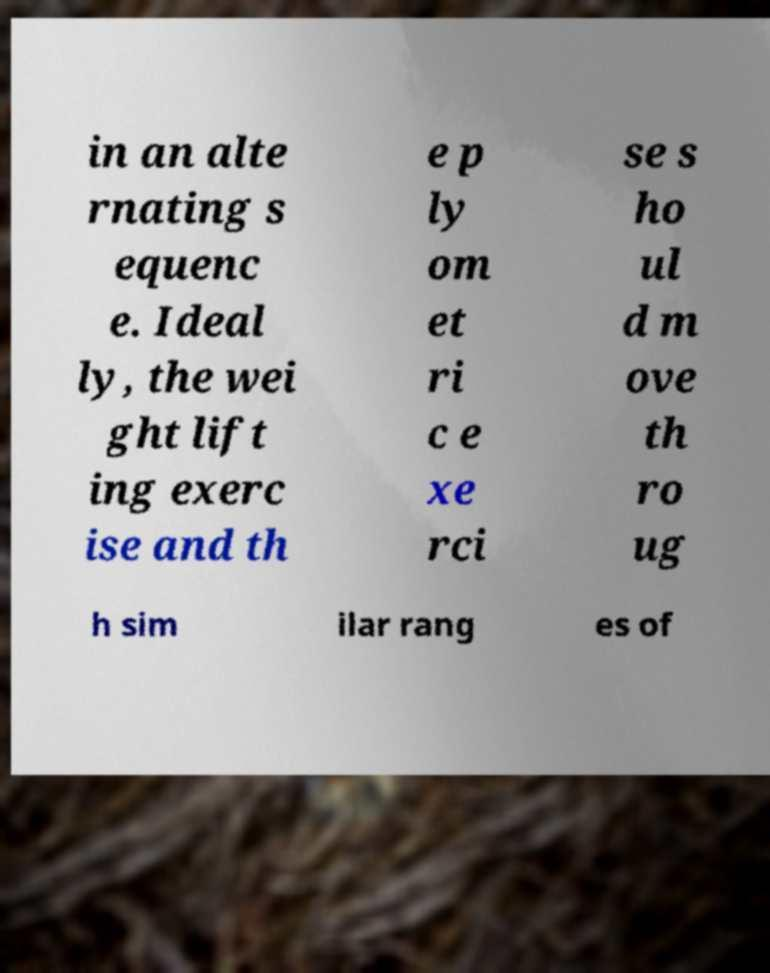Can you accurately transcribe the text from the provided image for me? in an alte rnating s equenc e. Ideal ly, the wei ght lift ing exerc ise and th e p ly om et ri c e xe rci se s ho ul d m ove th ro ug h sim ilar rang es of 